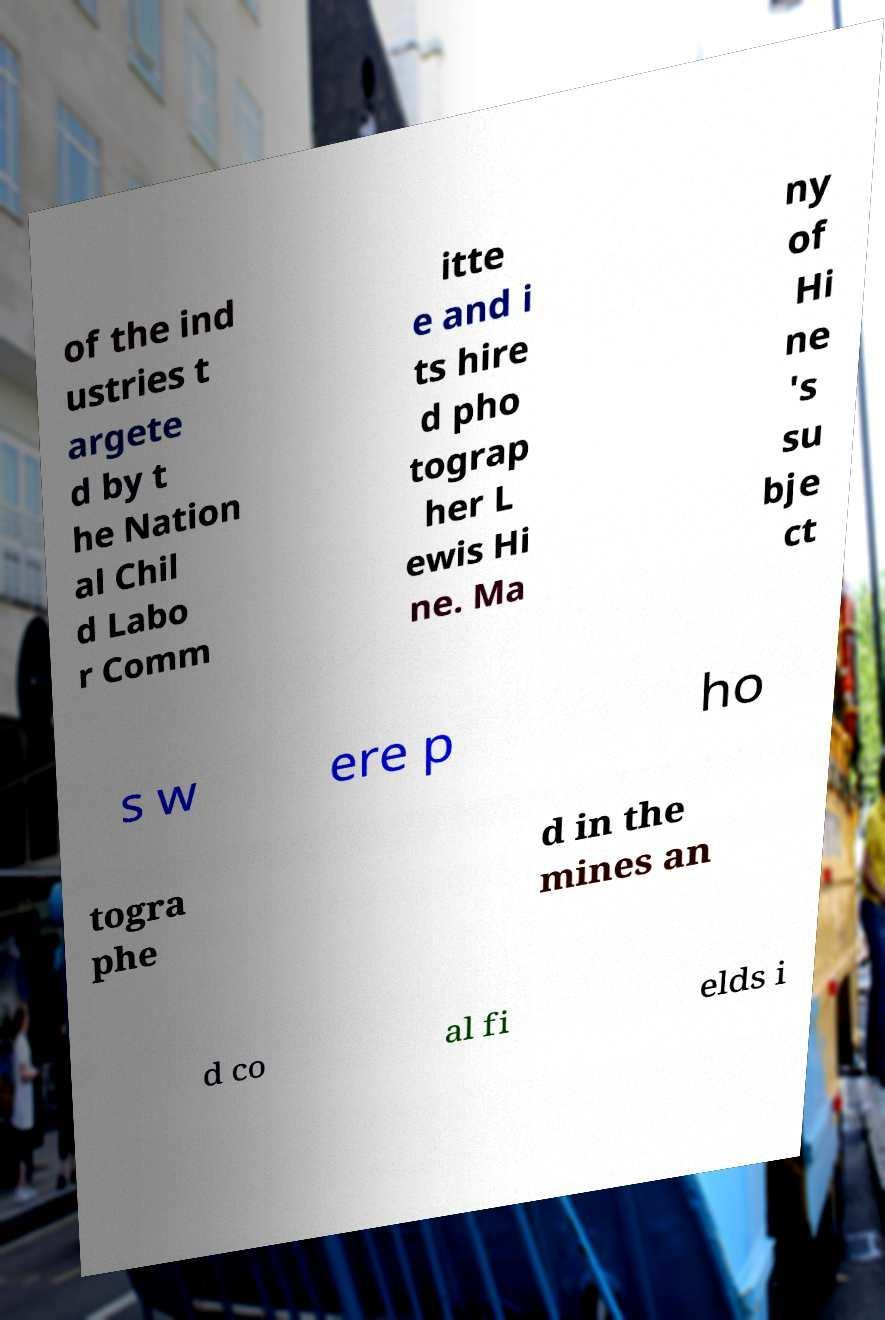I need the written content from this picture converted into text. Can you do that? of the ind ustries t argete d by t he Nation al Chil d Labo r Comm itte e and i ts hire d pho tograp her L ewis Hi ne. Ma ny of Hi ne 's su bje ct s w ere p ho togra phe d in the mines an d co al fi elds i 